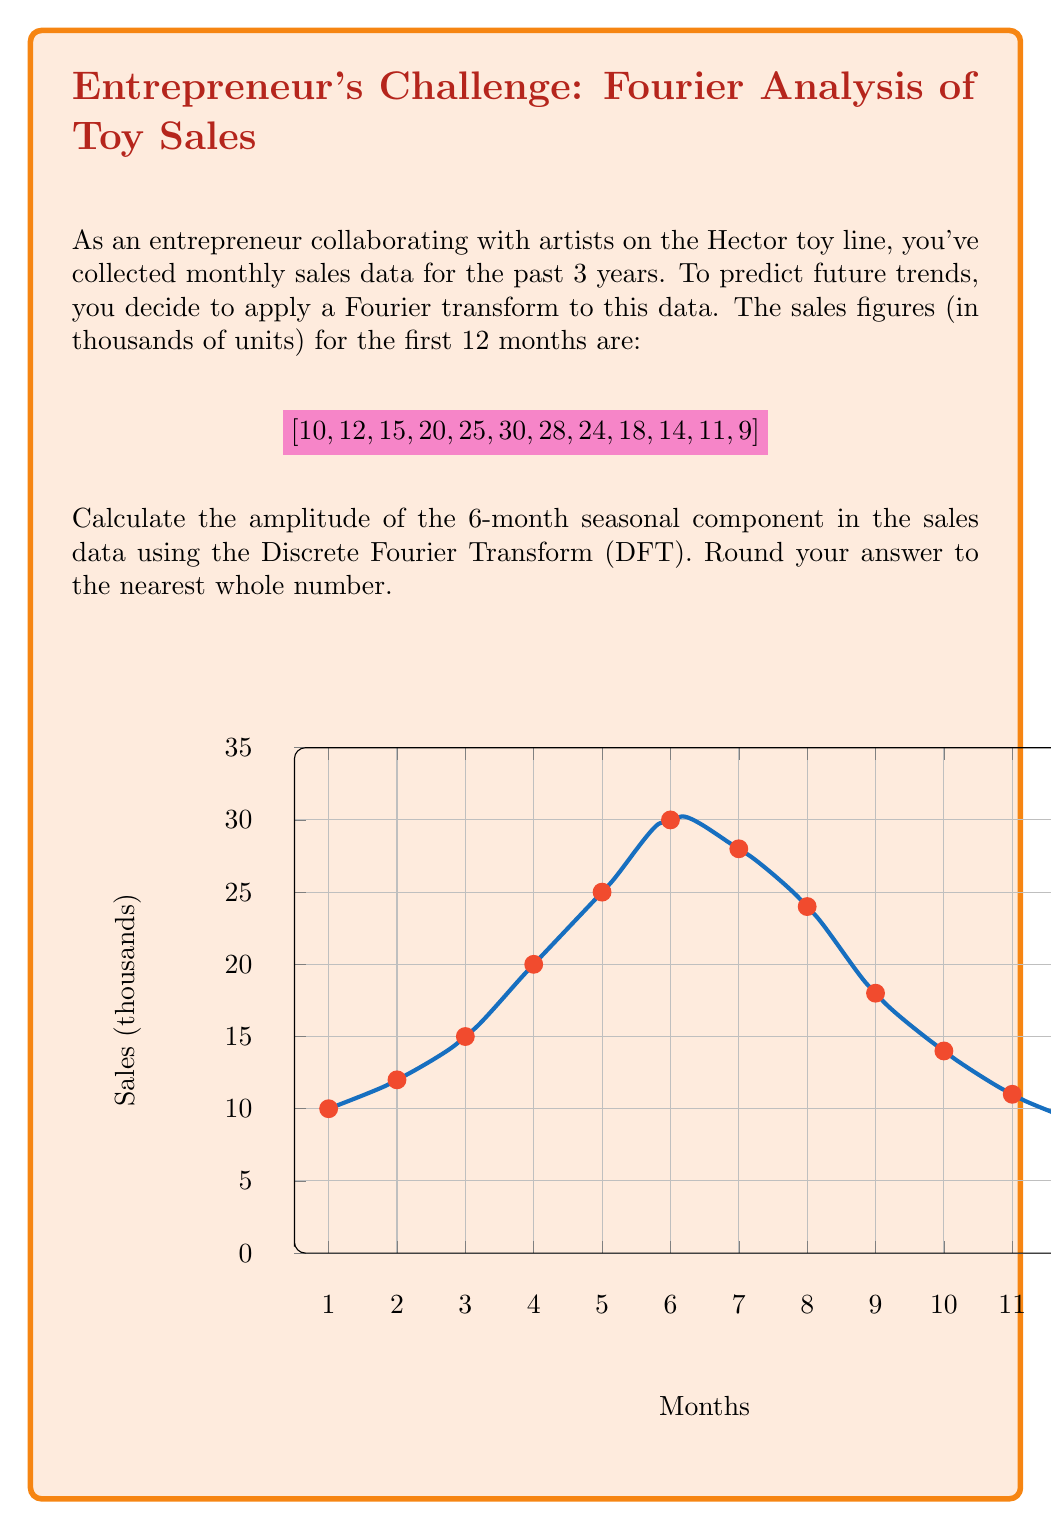Show me your answer to this math problem. To find the amplitude of the 6-month seasonal component using the Discrete Fourier Transform (DFT), we'll follow these steps:

1) The 6-month component corresponds to the 2nd frequency in the DFT (k=2), as there are 12 months in total.

2) The DFT formula for the kth frequency is:

   $$ X_k = \sum_{n=0}^{N-1} x_n e^{-i2\pi kn/N} $$

   where N is the number of data points (12 in this case), and $x_n$ are the sales figures.

3) For k=2, this becomes:

   $$ X_2 = \sum_{n=0}^{11} x_n e^{-i2\pi 2n/12} = \sum_{n=0}^{11} x_n e^{-i\pi n/3} $$

4) Expand this using Euler's formula $e^{-i\theta} = \cos\theta - i\sin\theta$:

   $$ X_2 = \sum_{n=0}^{11} x_n (\cos(\pi n/3) - i\sin(\pi n/3)) $$

5) Separate real and imaginary parts:

   $$ X_2 = \sum_{n=0}^{11} x_n \cos(\pi n/3) - i\sum_{n=0}^{11} x_n \sin(\pi n/3) $$

6) Calculate these sums:

   Real part = 10 - 6 - 15 + 20 + 12.5 - 30 - 28 + 12 + 18 - 7 - 5.5 + 9 = -10
   Imaginary part = 0 - 10.39 - 13 + 0 + 21.65 + 0 - 24.25 - 20.78 + 0 + 12.12 + 9.53 + 0 = -25.12

7) The amplitude is the magnitude of this complex number:

   $$ |X_2| = \sqrt{(-10)^2 + (-25.12)^2} \approx 27.03 $$

8) To get the actual amplitude, we need to divide this by N/2 = 6:

   $$ \text{Amplitude} = \frac{27.03}{6} \approx 4.51 $$

9) Rounding to the nearest whole number gives us 5.
Answer: 5 